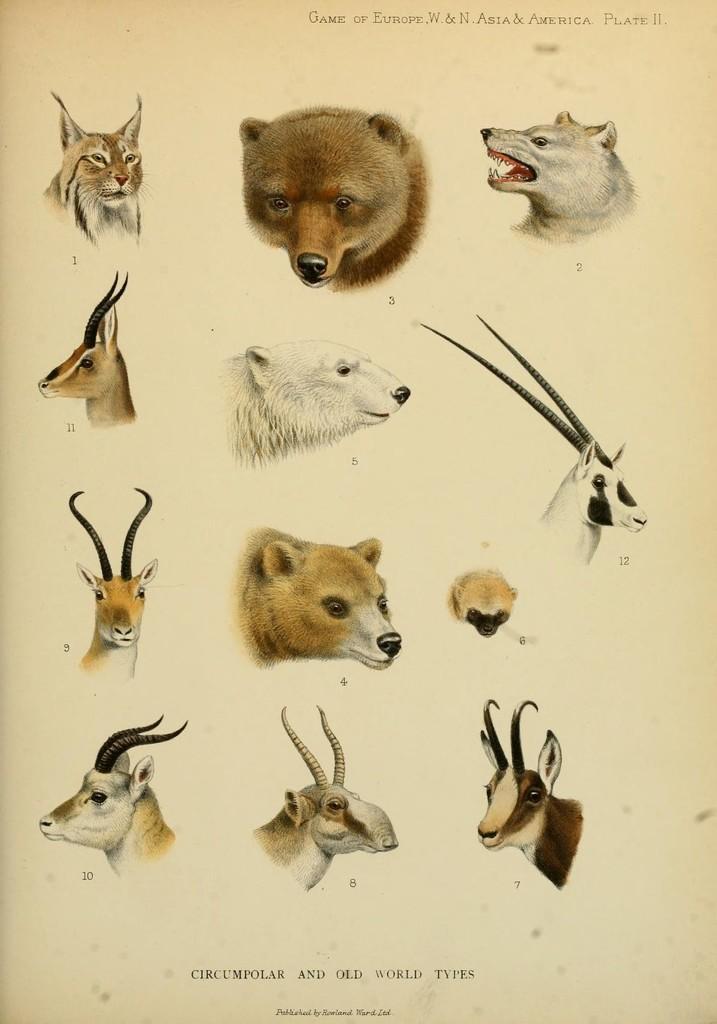Could you give a brief overview of what you see in this image? In the image there are images of various animal heads on the paper, that includes bear,deer,wild cat,wild goat etc., 